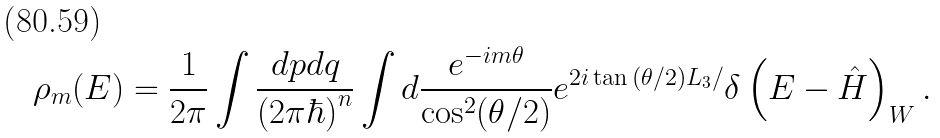<formula> <loc_0><loc_0><loc_500><loc_500>\rho _ { m } ( E ) = \frac { 1 } { 2 \pi } \int \frac { d { p } d { q } } { ( 2 \pi \hbar { ) } ^ { n } } \int d \frac { e ^ { - i m \theta } } { \cos ^ { 2 } ( \theta / 2 ) } e ^ { 2 i \tan { ( \theta / 2 ) } L _ { 3 } / } \delta \left ( E - \hat { H } \right ) _ { W } .</formula> 